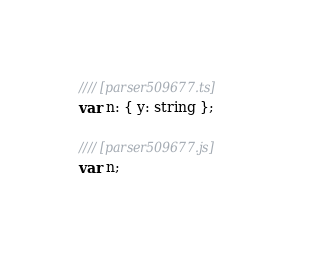<code> <loc_0><loc_0><loc_500><loc_500><_JavaScript_>//// [parser509677.ts]
var n: { y: string };

//// [parser509677.js]
var n;
</code> 